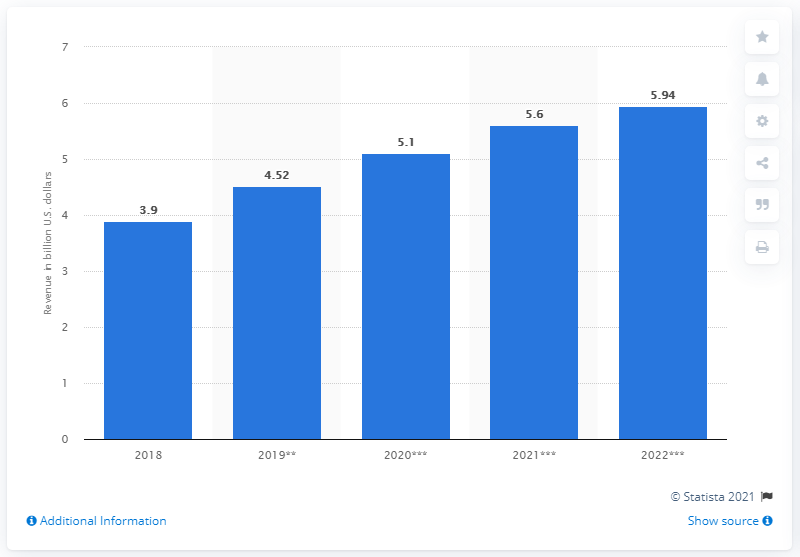Give some essential details in this illustration. The estimated revenue of connected home products in the United States in 2020 was $5.1 billion. 